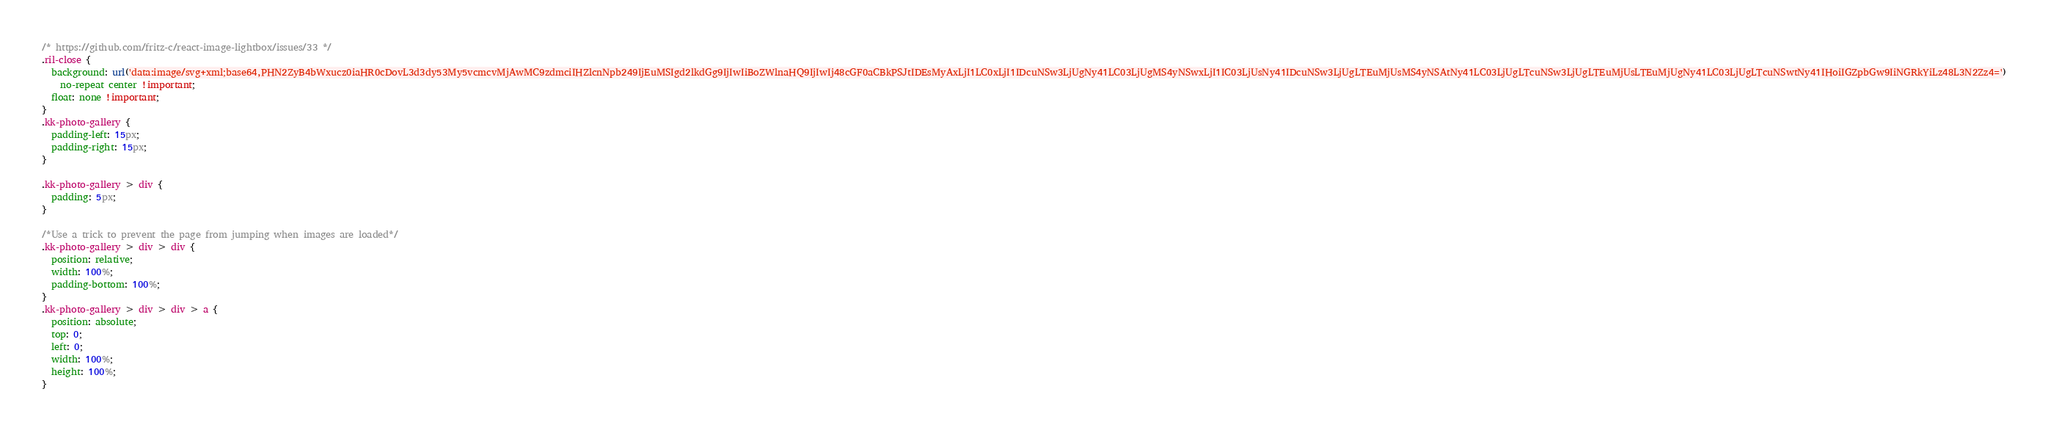Convert code to text. <code><loc_0><loc_0><loc_500><loc_500><_CSS_>/* https://github.com/fritz-c/react-image-lightbox/issues/33 */
.ril-close {
  background: url('data:image/svg+xml;base64,PHN2ZyB4bWxucz0iaHR0cDovL3d3dy53My5vcmcvMjAwMC9zdmciIHZlcnNpb249IjEuMSIgd2lkdGg9IjIwIiBoZWlnaHQ9IjIwIj48cGF0aCBkPSJtIDEsMyAxLjI1LC0xLjI1IDcuNSw3LjUgNy41LC03LjUgMS4yNSwxLjI1IC03LjUsNy41IDcuNSw3LjUgLTEuMjUsMS4yNSAtNy41LC03LjUgLTcuNSw3LjUgLTEuMjUsLTEuMjUgNy41LC03LjUgLTcuNSwtNy41IHoiIGZpbGw9IiNGRkYiLz48L3N2Zz4=')
    no-repeat center !important;
  float: none !important;
}
.kk-photo-gallery {
  padding-left: 15px;
  padding-right: 15px;
}

.kk-photo-gallery > div {
  padding: 5px;
}

/*Use a trick to prevent the page from jumping when images are loaded*/
.kk-photo-gallery > div > div {
  position: relative;
  width: 100%;
  padding-bottom: 100%;
}
.kk-photo-gallery > div > div > a {
  position: absolute;
  top: 0;
  left: 0;
  width: 100%;
  height: 100%;
}
</code> 